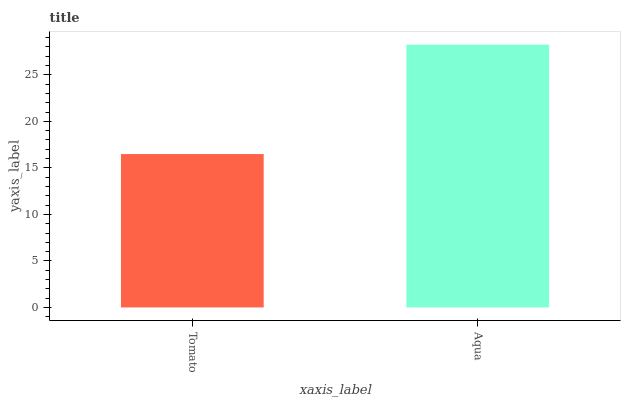Is Tomato the minimum?
Answer yes or no. Yes. Is Aqua the maximum?
Answer yes or no. Yes. Is Aqua the minimum?
Answer yes or no. No. Is Aqua greater than Tomato?
Answer yes or no. Yes. Is Tomato less than Aqua?
Answer yes or no. Yes. Is Tomato greater than Aqua?
Answer yes or no. No. Is Aqua less than Tomato?
Answer yes or no. No. Is Aqua the high median?
Answer yes or no. Yes. Is Tomato the low median?
Answer yes or no. Yes. Is Tomato the high median?
Answer yes or no. No. Is Aqua the low median?
Answer yes or no. No. 